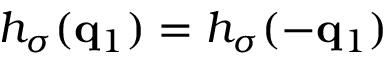Convert formula to latex. <formula><loc_0><loc_0><loc_500><loc_500>h _ { \sigma } ( q _ { 1 } ) = h _ { \sigma } ( - q _ { 1 } )</formula> 